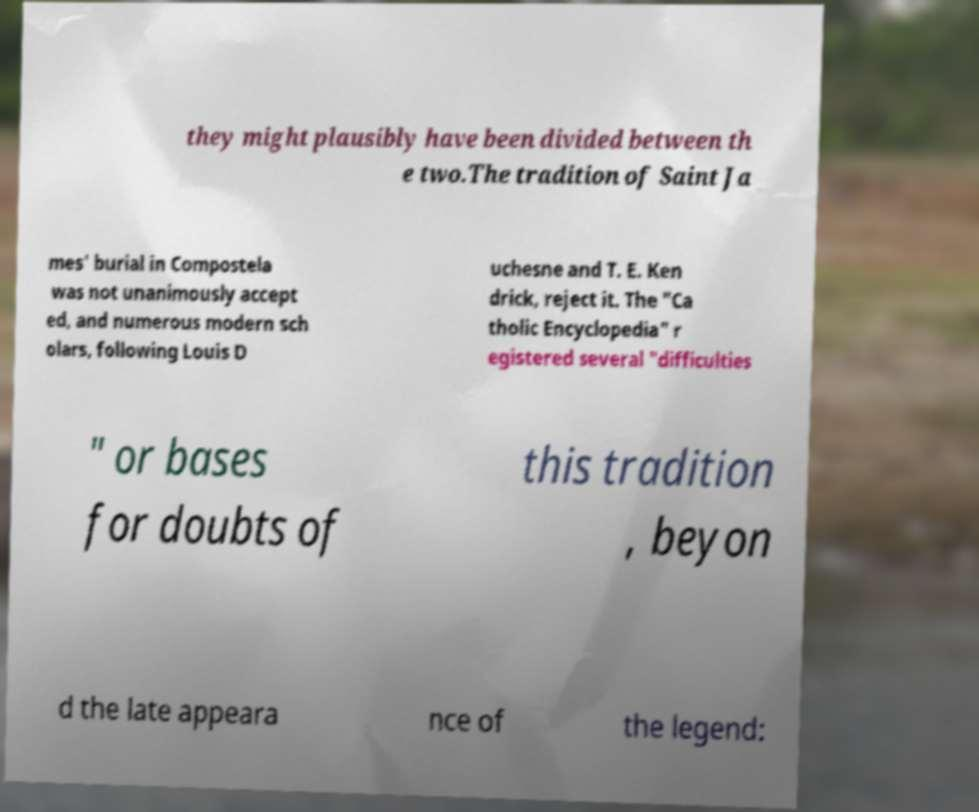There's text embedded in this image that I need extracted. Can you transcribe it verbatim? they might plausibly have been divided between th e two.The tradition of Saint Ja mes' burial in Compostela was not unanimously accept ed, and numerous modern sch olars, following Louis D uchesne and T. E. Ken drick, reject it. The "Ca tholic Encyclopedia" r egistered several "difficulties " or bases for doubts of this tradition , beyon d the late appeara nce of the legend: 